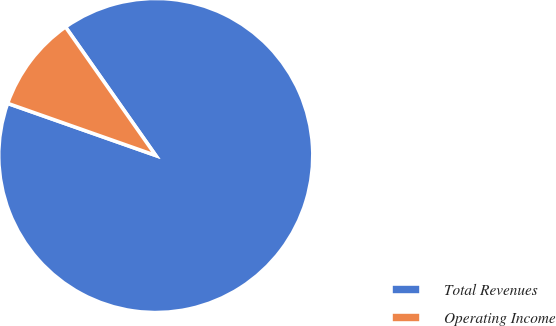<chart> <loc_0><loc_0><loc_500><loc_500><pie_chart><fcel>Total Revenues<fcel>Operating Income<nl><fcel>90.13%<fcel>9.87%<nl></chart> 